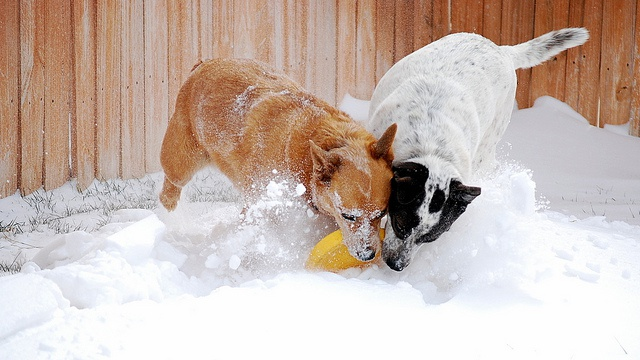Describe the objects in this image and their specific colors. I can see dog in brown, salmon, and tan tones, dog in brown, lightgray, black, darkgray, and gray tones, and frisbee in brown, tan, orange, and olive tones in this image. 